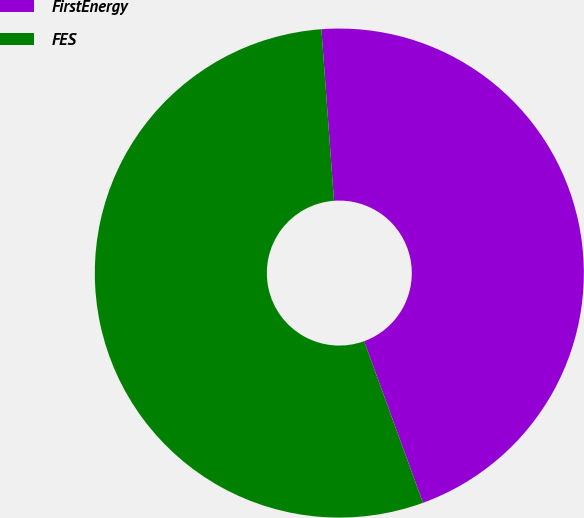<chart> <loc_0><loc_0><loc_500><loc_500><pie_chart><fcel>FirstEnergy<fcel>FES<nl><fcel>45.61%<fcel>54.39%<nl></chart> 